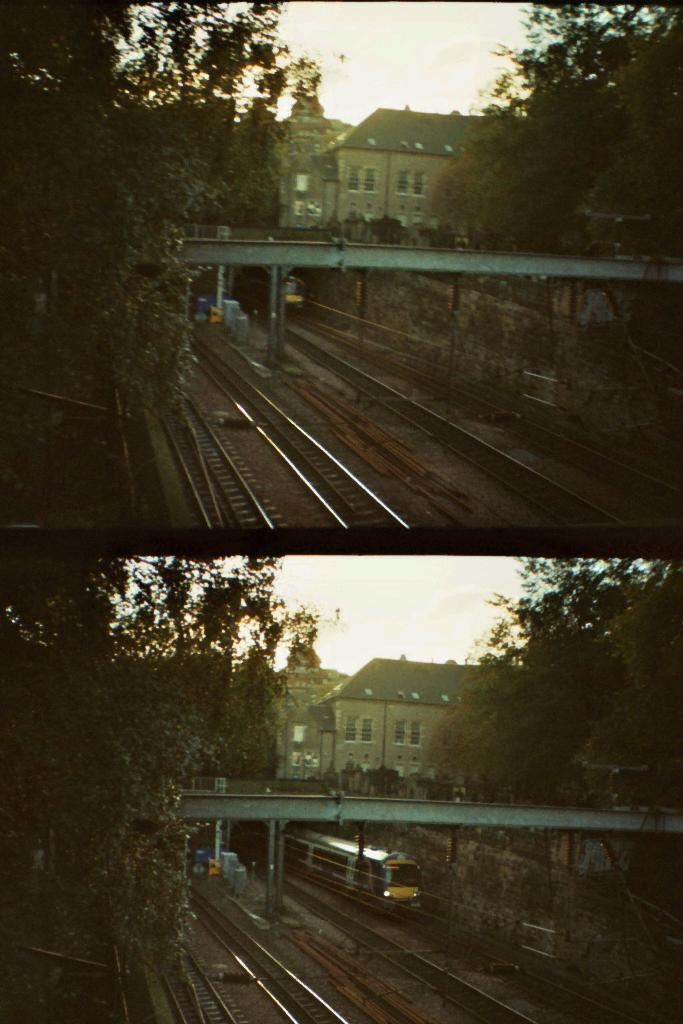What type of artwork is the image? The image is a collage. What structures can be seen in the collage? There are buildings in the image. What transportation-related feature is present in the image? Railway tracks are present in the image. What type of vegetation is visible in the image? Trees are visible in the image. What is on the railway tracks in the image? There is a train on the railway tracks. What can be seen in the background of the image? The sky is visible in the background of the image. What type of muscle is being exercised by the pig in the image? There is no pig present in the image, and therefore no muscle exercise can be observed. What type of humor is depicted in the image? The image does not contain any humor; it is a collage featuring buildings, railway tracks, trees, a train, and the sky. 